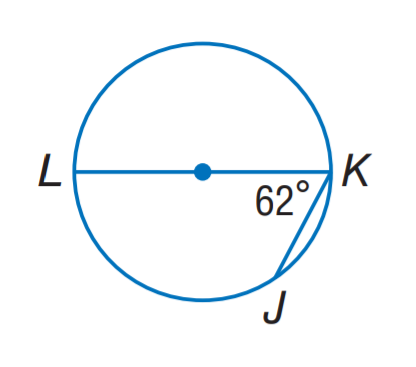Question: Find m \widehat J K.
Choices:
A. 34
B. 48
C. 56
D. 62
Answer with the letter. Answer: C 